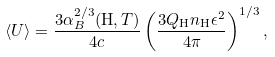<formula> <loc_0><loc_0><loc_500><loc_500>\langle U \rangle = \frac { 3 \alpha _ { B } ^ { 2 / 3 } ( { \mathrm H } , T ) } { 4 c } \left ( \frac { 3 Q _ { \mathrm H } n _ { \mathrm H } \epsilon ^ { 2 } } { 4 \pi } \right ) ^ { 1 / 3 } ,</formula> 